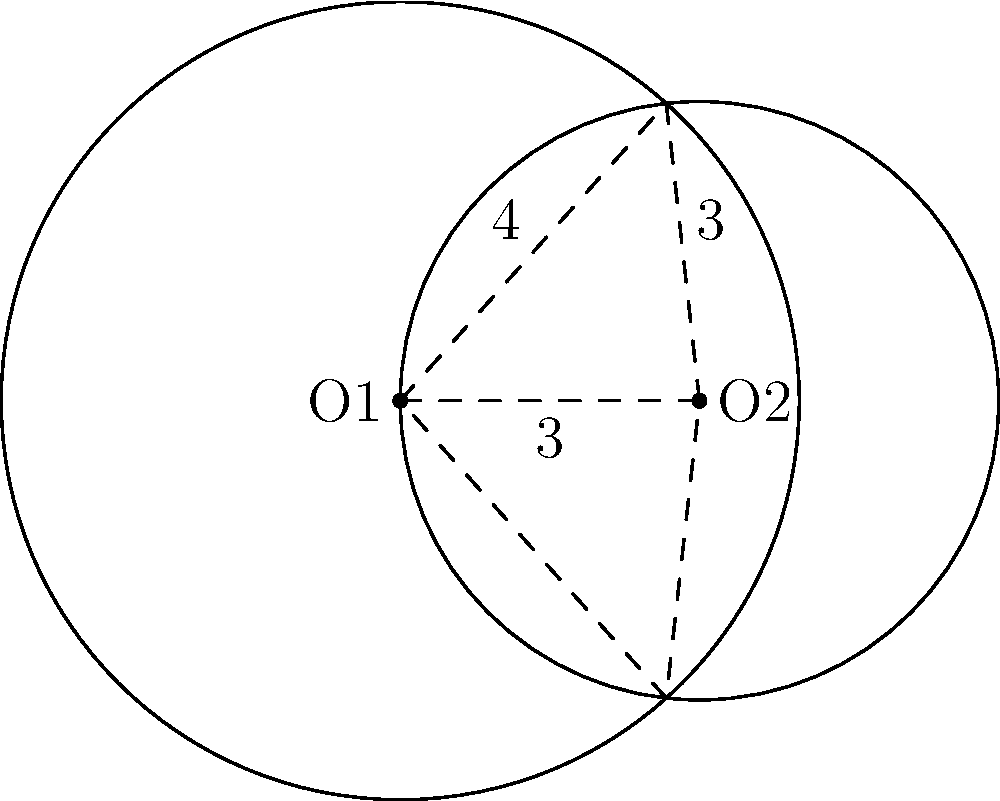In a commercial kitchen, two circular sanitation zones overlap as shown in the diagram. The centers of the circles are 3 feet apart. The radius of the larger circle (centered at O1) is 4 feet, and the radius of the smaller circle (centered at O2) is 3 feet. Calculate the area of the overlapping region to determine the zone that requires double sanitation efforts. Round your answer to the nearest square foot. To find the area of overlap between two circles, we can use the formula:

$$A = r_1^2 \arccos(\frac{d^2 + r_1^2 - r_2^2}{2dr_1}) + r_2^2 \arccos(\frac{d^2 + r_2^2 - r_1^2}{2dr_2}) - \frac{1}{2}\sqrt{(-d+r_1+r_2)(d+r_1-r_2)(d-r_1+r_2)(d+r_1+r_2)}$$

Where:
$A$ = area of overlap
$r_1$ = radius of the larger circle (4 feet)
$r_2$ = radius of the smaller circle (3 feet)
$d$ = distance between centers (3 feet)

Step 1: Calculate the first term
$$4^2 \arccos(\frac{3^2 + 4^2 - 3^2}{2 \cdot 3 \cdot 4}) = 16 \arccos(0.9583) = 16 \cdot 0.2902 = 4.6432$$

Step 2: Calculate the second term
$$3^2 \arccos(\frac{3^2 + 3^2 - 4^2}{2 \cdot 3 \cdot 3}) = 9 \arccos(0.5) = 9 \cdot 1.0472 = 9.4248$$

Step 3: Calculate the third term
$$\frac{1}{2}\sqrt{(-3+4+3)(3+4-3)(3-4+3)(3+4+3)} = \frac{1}{2}\sqrt{4 \cdot 4 \cdot 2 \cdot 10} = 4.4721$$

Step 4: Sum up the results
$$A = 4.6432 + 9.4248 - 4.4721 = 9.5959$$

Step 5: Round to the nearest square foot
$$9.5959 \approx 10 \text{ sq ft}$$
Answer: 10 sq ft 